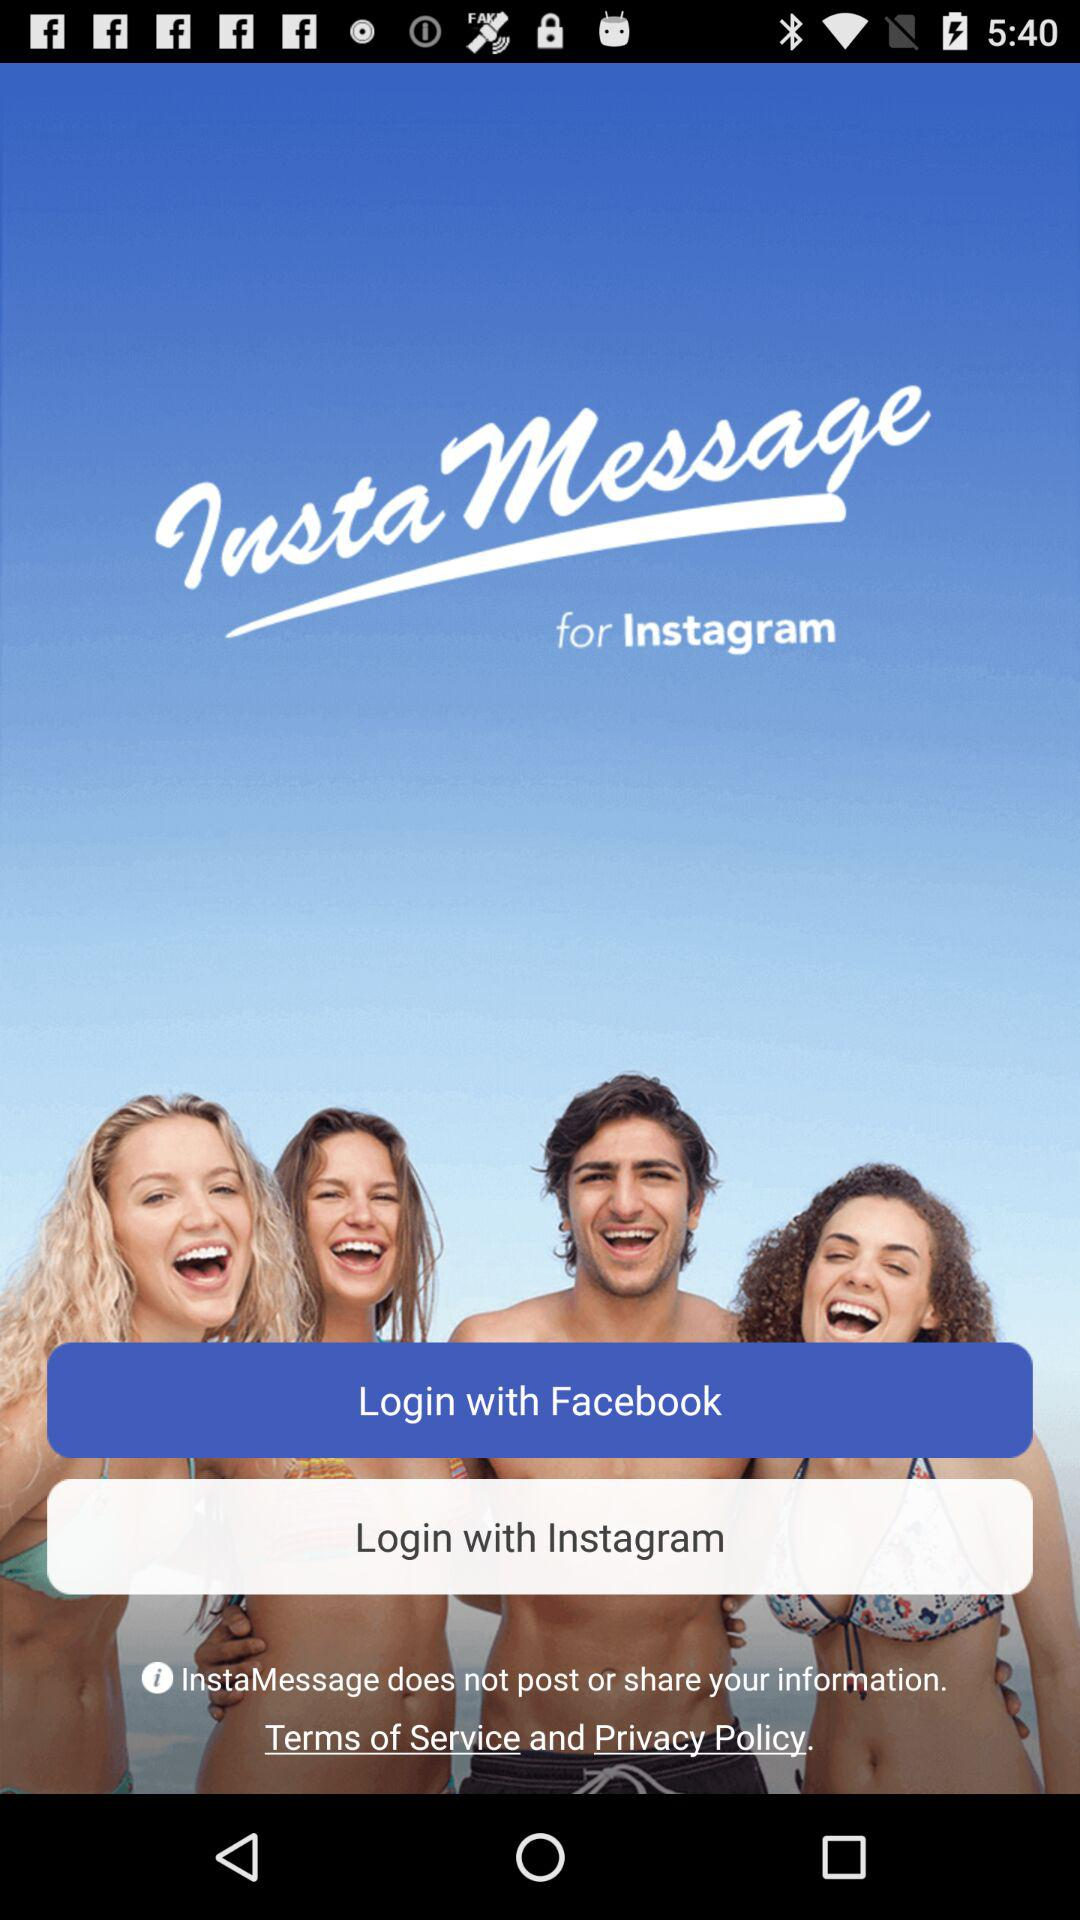What is the name of the application? The name of the application is "InstaMessage". 